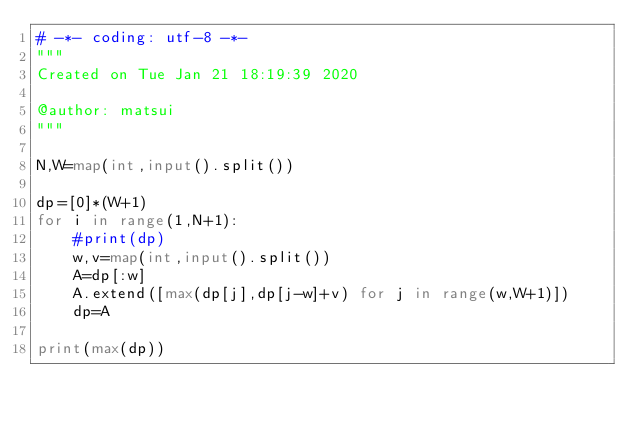Convert code to text. <code><loc_0><loc_0><loc_500><loc_500><_Python_># -*- coding: utf-8 -*-
"""
Created on Tue Jan 21 18:19:39 2020

@author: matsui
"""

N,W=map(int,input().split())

dp=[0]*(W+1)
for i in range(1,N+1):
    #print(dp)
    w,v=map(int,input().split())
    A=dp[:w]
    A.extend([max(dp[j],dp[j-w]+v) for j in range(w,W+1)])
    dp=A
   
print(max(dp))
</code> 